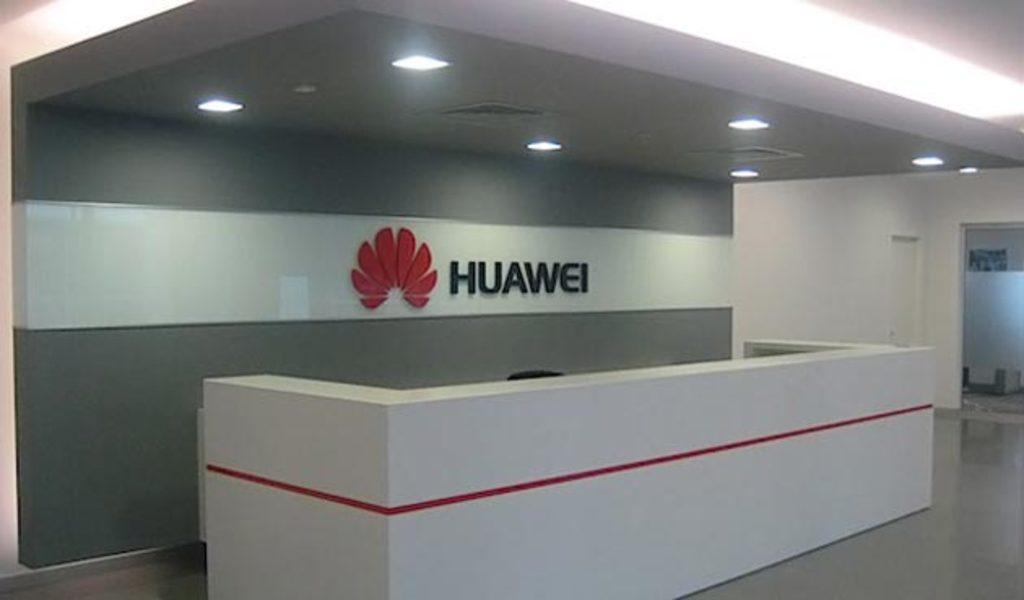In one or two sentences, can you explain what this image depicts? In this image there is a front room table in bottom of this image and there is a wall in middle of this image and there is text with logo in middle of this image. There are some lights fixed at top of this image and there is a door at right side of this image. 